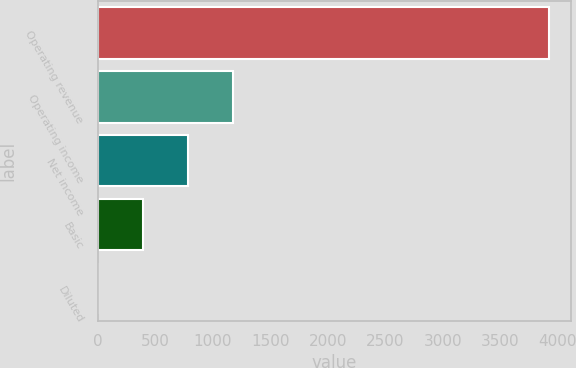Convert chart. <chart><loc_0><loc_0><loc_500><loc_500><bar_chart><fcel>Operating revenue<fcel>Operating income<fcel>Net income<fcel>Basic<fcel>Diluted<nl><fcel>3923<fcel>1177.92<fcel>785.76<fcel>393.6<fcel>1.44<nl></chart> 